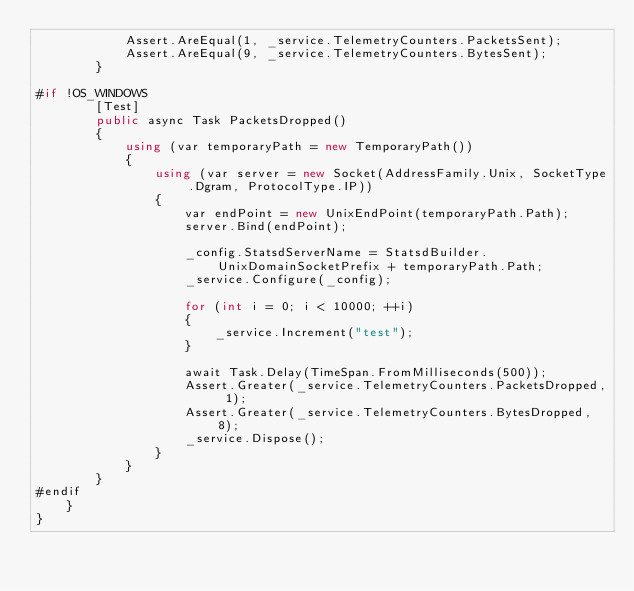Convert code to text. <code><loc_0><loc_0><loc_500><loc_500><_C#_>            Assert.AreEqual(1, _service.TelemetryCounters.PacketsSent);
            Assert.AreEqual(9, _service.TelemetryCounters.BytesSent);
        }

#if !OS_WINDOWS
        [Test]
        public async Task PacketsDropped()
        {
            using (var temporaryPath = new TemporaryPath())
            {
                using (var server = new Socket(AddressFamily.Unix, SocketType.Dgram, ProtocolType.IP))
                {
                    var endPoint = new UnixEndPoint(temporaryPath.Path);
                    server.Bind(endPoint);

                    _config.StatsdServerName = StatsdBuilder.UnixDomainSocketPrefix + temporaryPath.Path;
                    _service.Configure(_config);

                    for (int i = 0; i < 10000; ++i)
                    {
                        _service.Increment("test");
                    }

                    await Task.Delay(TimeSpan.FromMilliseconds(500));
                    Assert.Greater(_service.TelemetryCounters.PacketsDropped, 1);
                    Assert.Greater(_service.TelemetryCounters.BytesDropped, 8);
                    _service.Dispose();
                }
            }
        }
#endif
    }
}</code> 